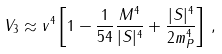<formula> <loc_0><loc_0><loc_500><loc_500>V _ { 3 } \approx v ^ { 4 } \left [ 1 - \frac { 1 } { 5 4 } \frac { M ^ { 4 } } { | S | ^ { 4 } } + \frac { | S | ^ { 4 } } { 2 m ^ { 4 } _ { P } } \right ] \, ,</formula> 